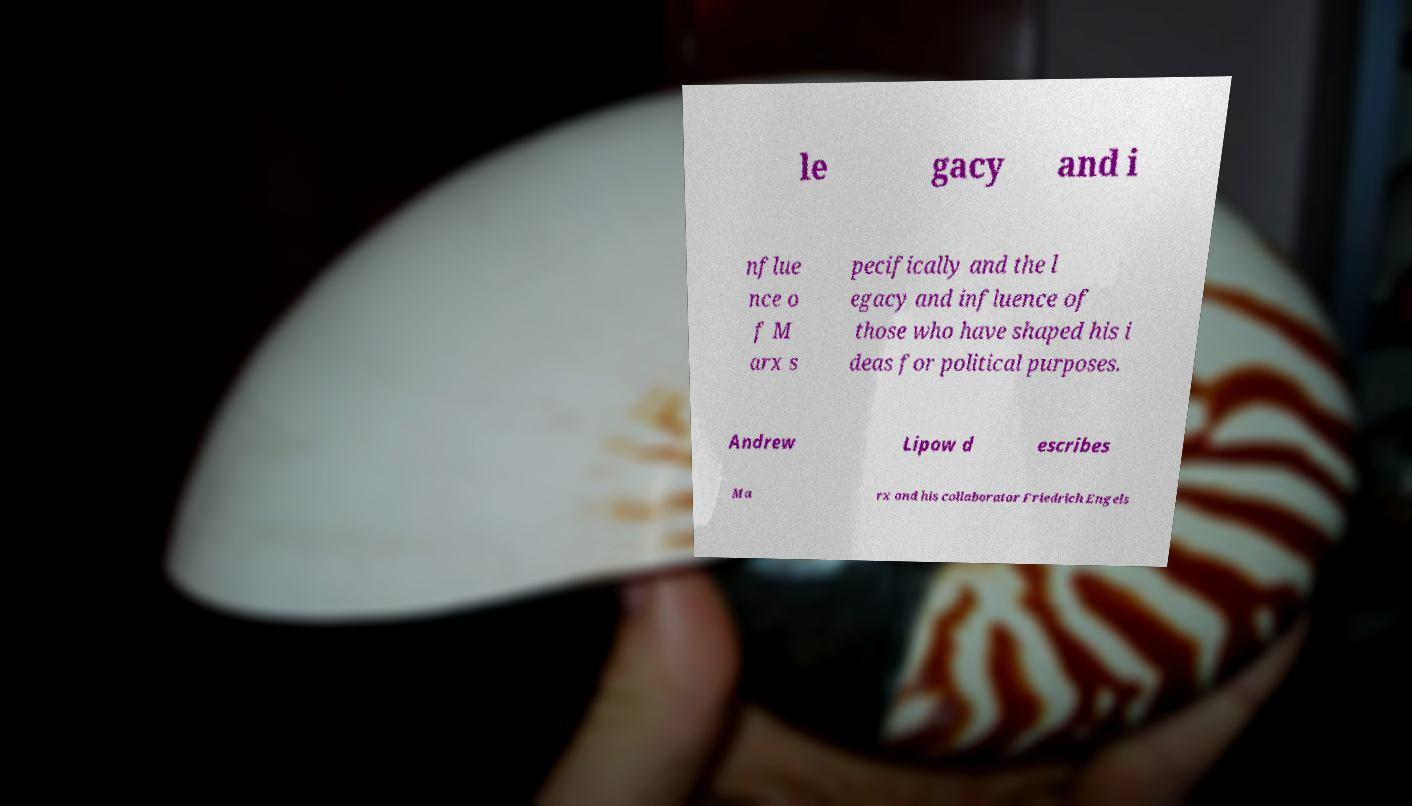I need the written content from this picture converted into text. Can you do that? le gacy and i nflue nce o f M arx s pecifically and the l egacy and influence of those who have shaped his i deas for political purposes. Andrew Lipow d escribes Ma rx and his collaborator Friedrich Engels 